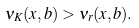<formula> <loc_0><loc_0><loc_500><loc_500>\nu _ { K } ( x , b ) > \nu _ { r } ( x , b ) .</formula> 